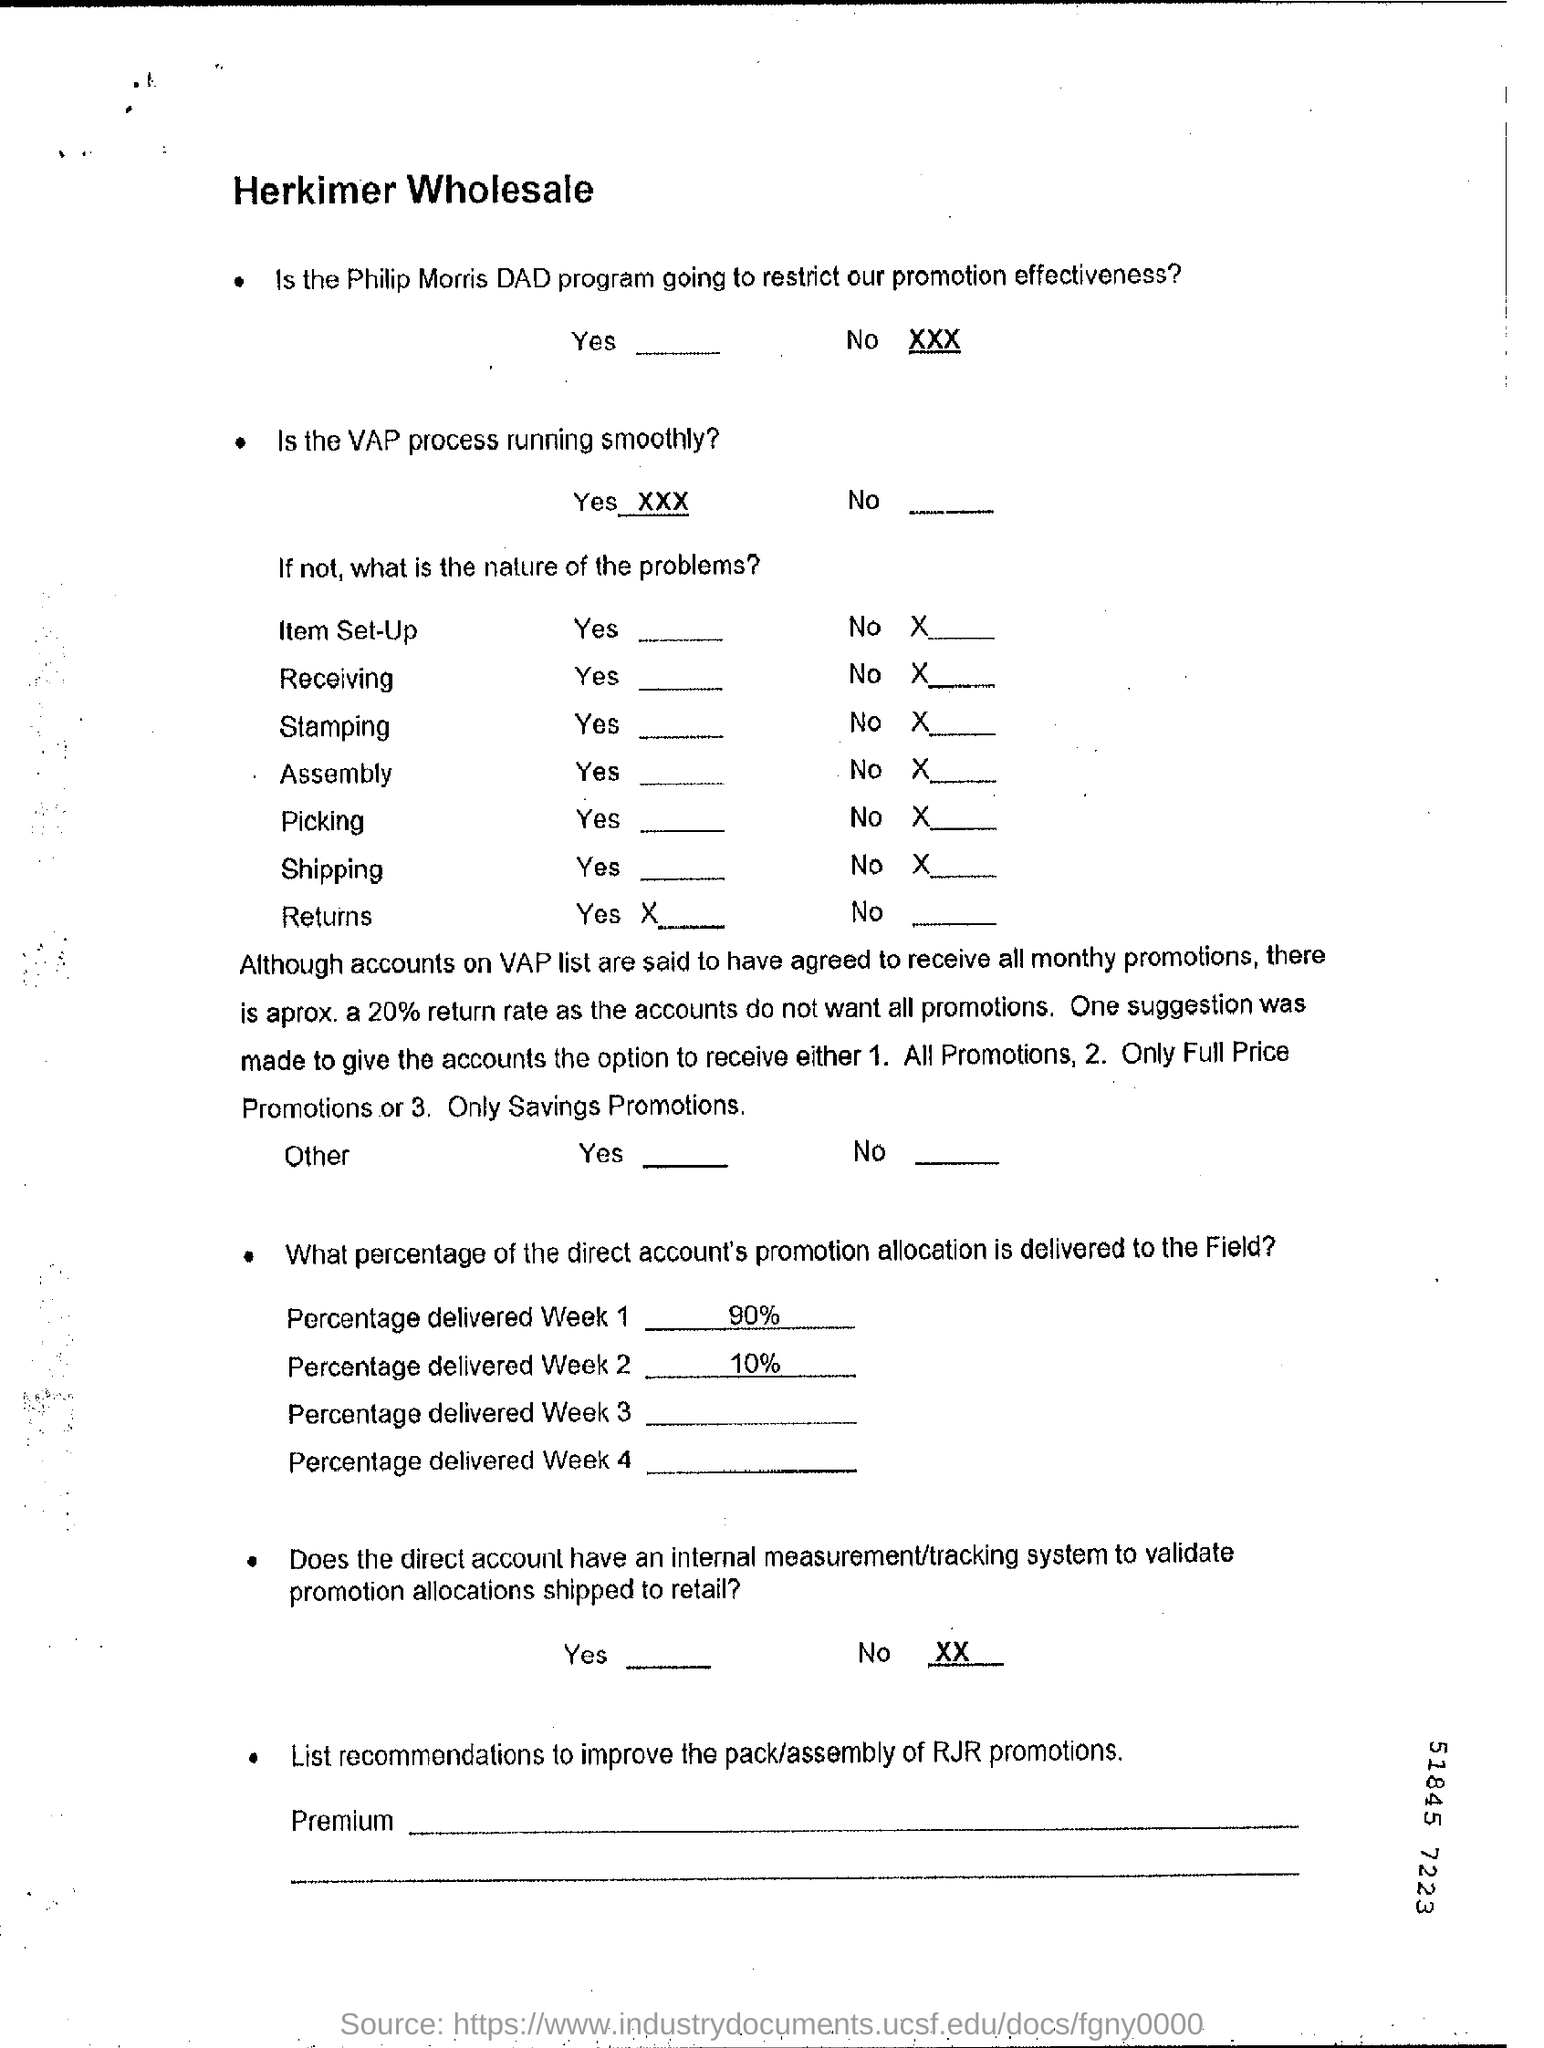Is the philip morris DAD program going to restrict our promotion effectiveness ?
Make the answer very short. No. Is the VAP process running smoothly ?
Offer a terse response. Yes. What percentage of the direct account's promotion allocation is delivered to the field in week 1 ?
Ensure brevity in your answer.  90%. What percentage of the direct account's promotion allocation is delivered to the field in week 2 ?
Your answer should be compact. 10% . 